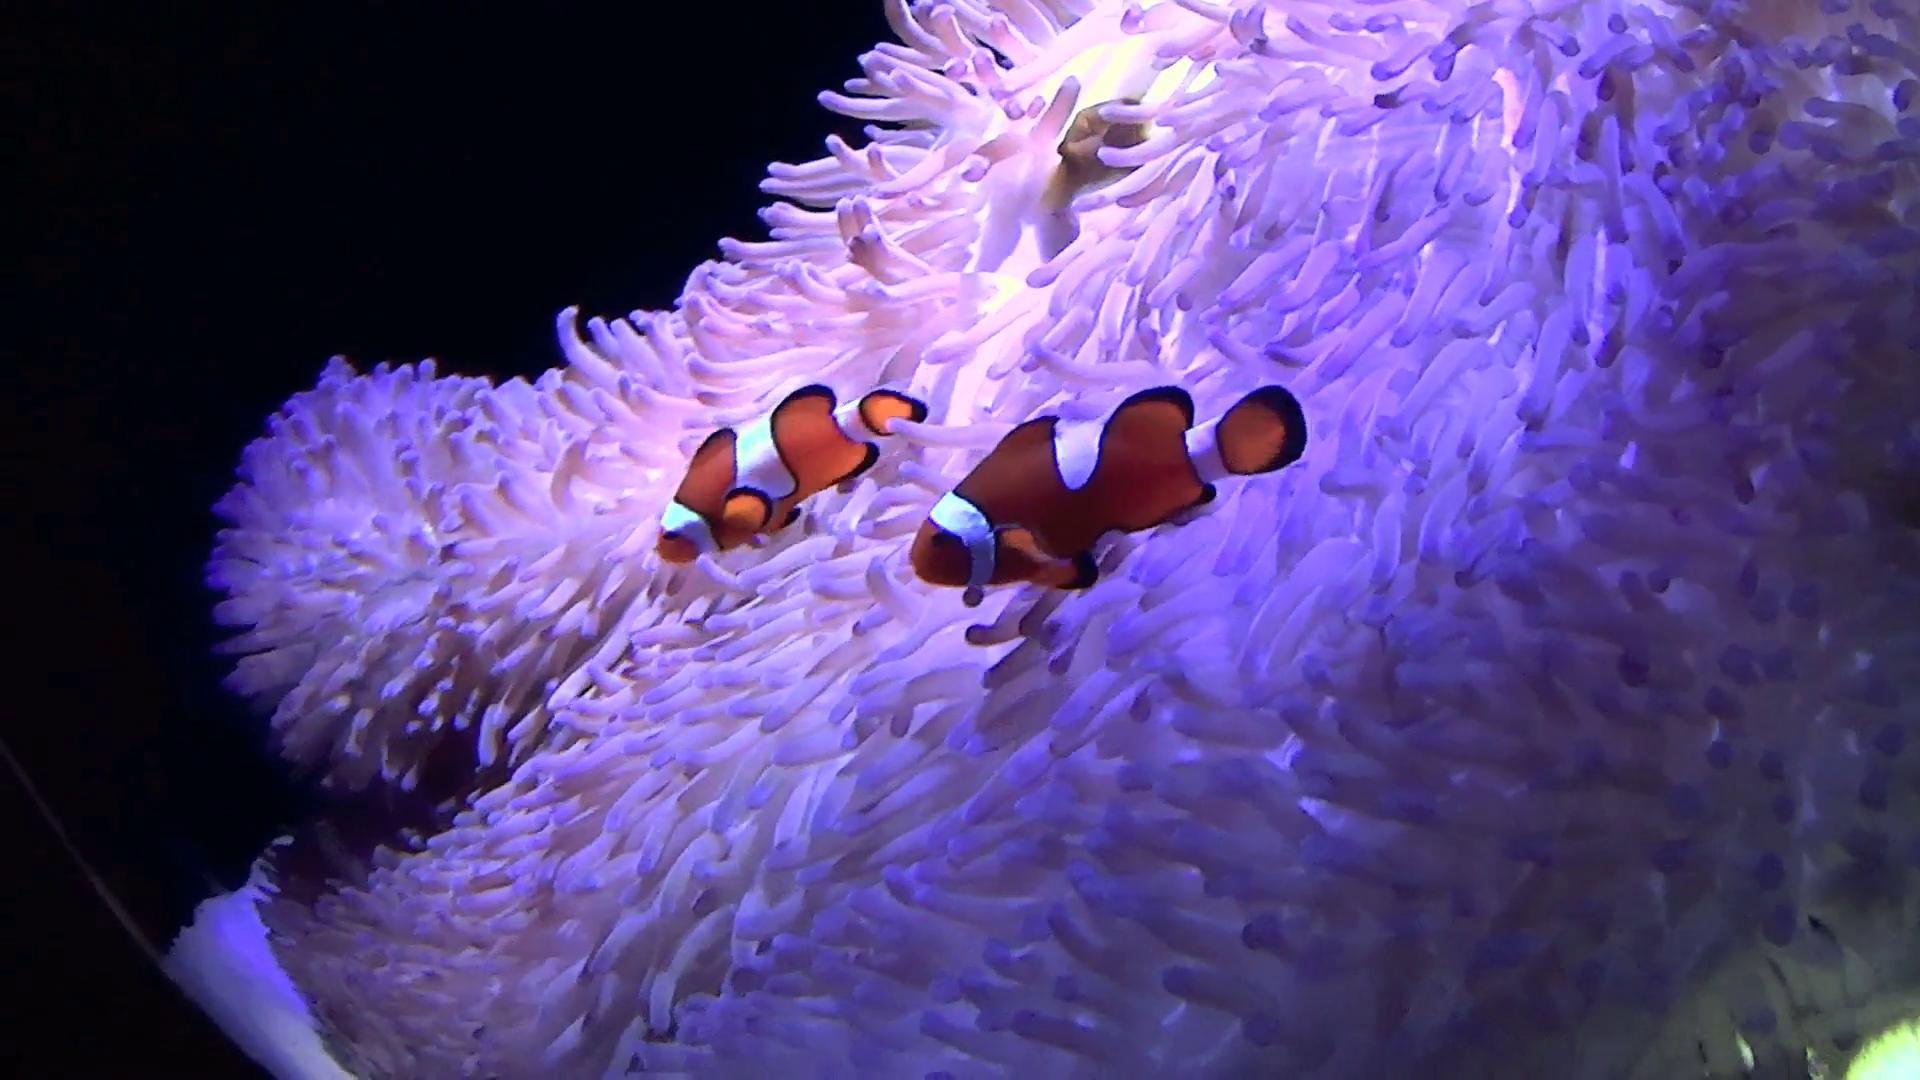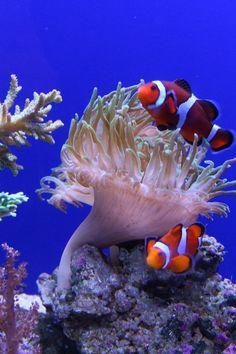The first image is the image on the left, the second image is the image on the right. Considering the images on both sides, is "Only one of the images has a fish in it." valid? Answer yes or no. No. 